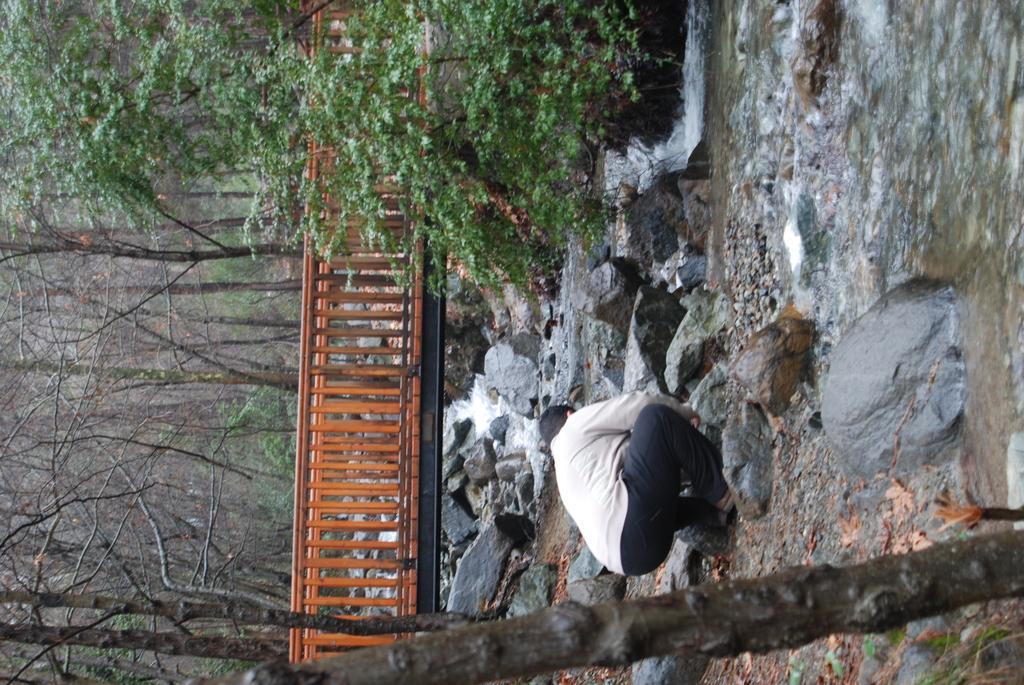Please provide a concise description of this image. In this image we can see this person wearing T-shirt and black trouser is on the rocks. Here we can see the water, we can see rocks, wooden bridge and trees in the background. 